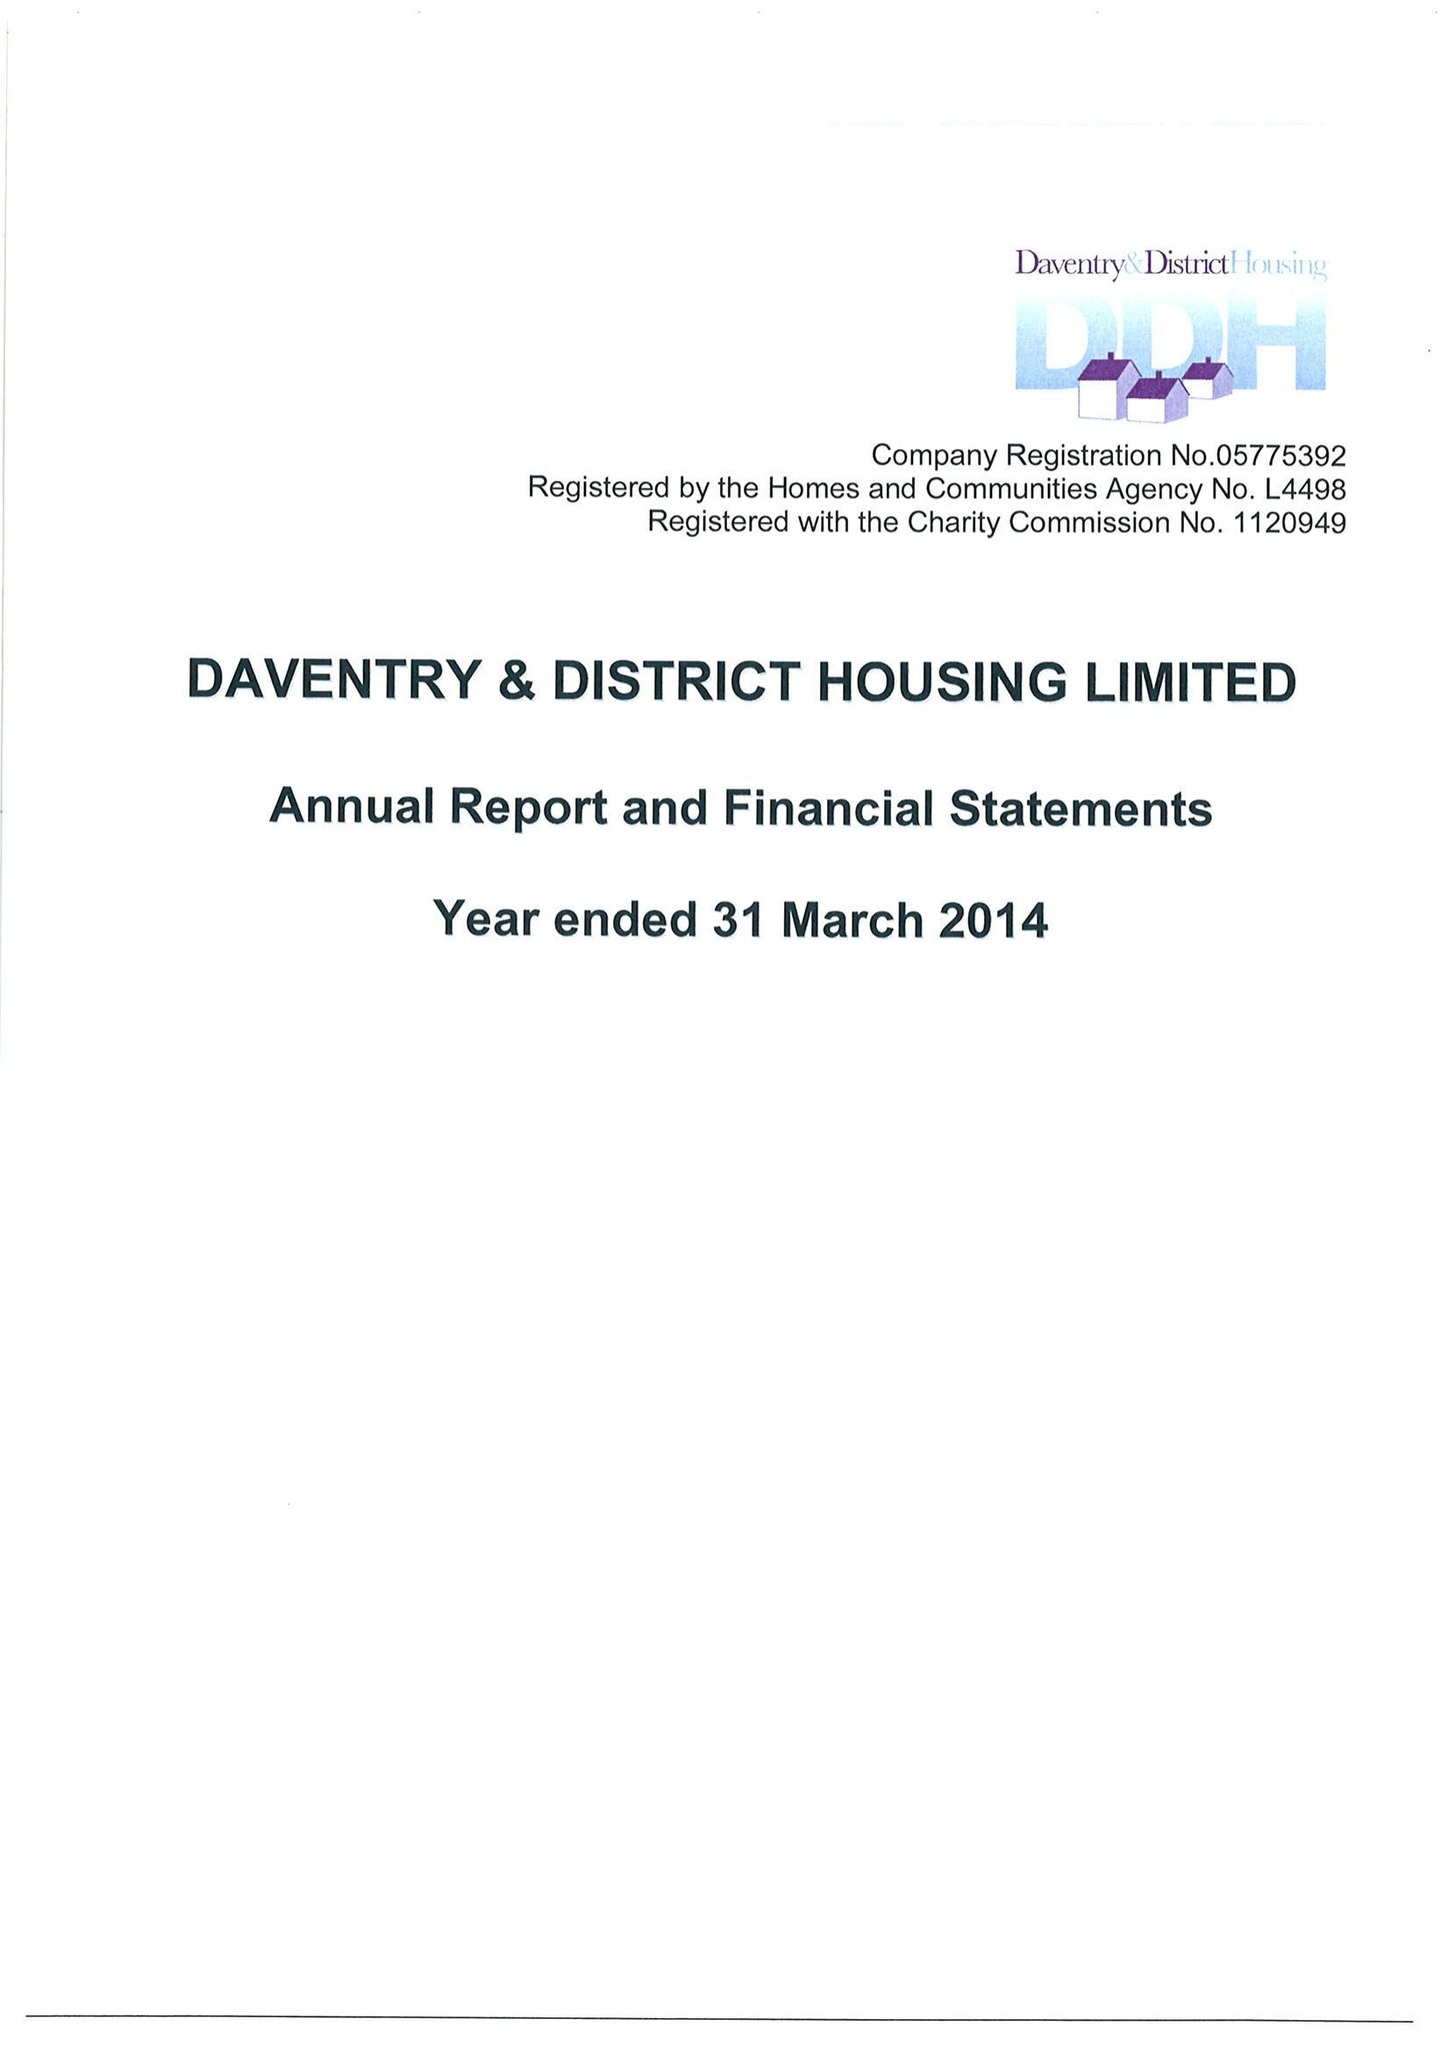What is the value for the spending_annually_in_british_pounds?
Answer the question using a single word or phrase. 14027000.00 